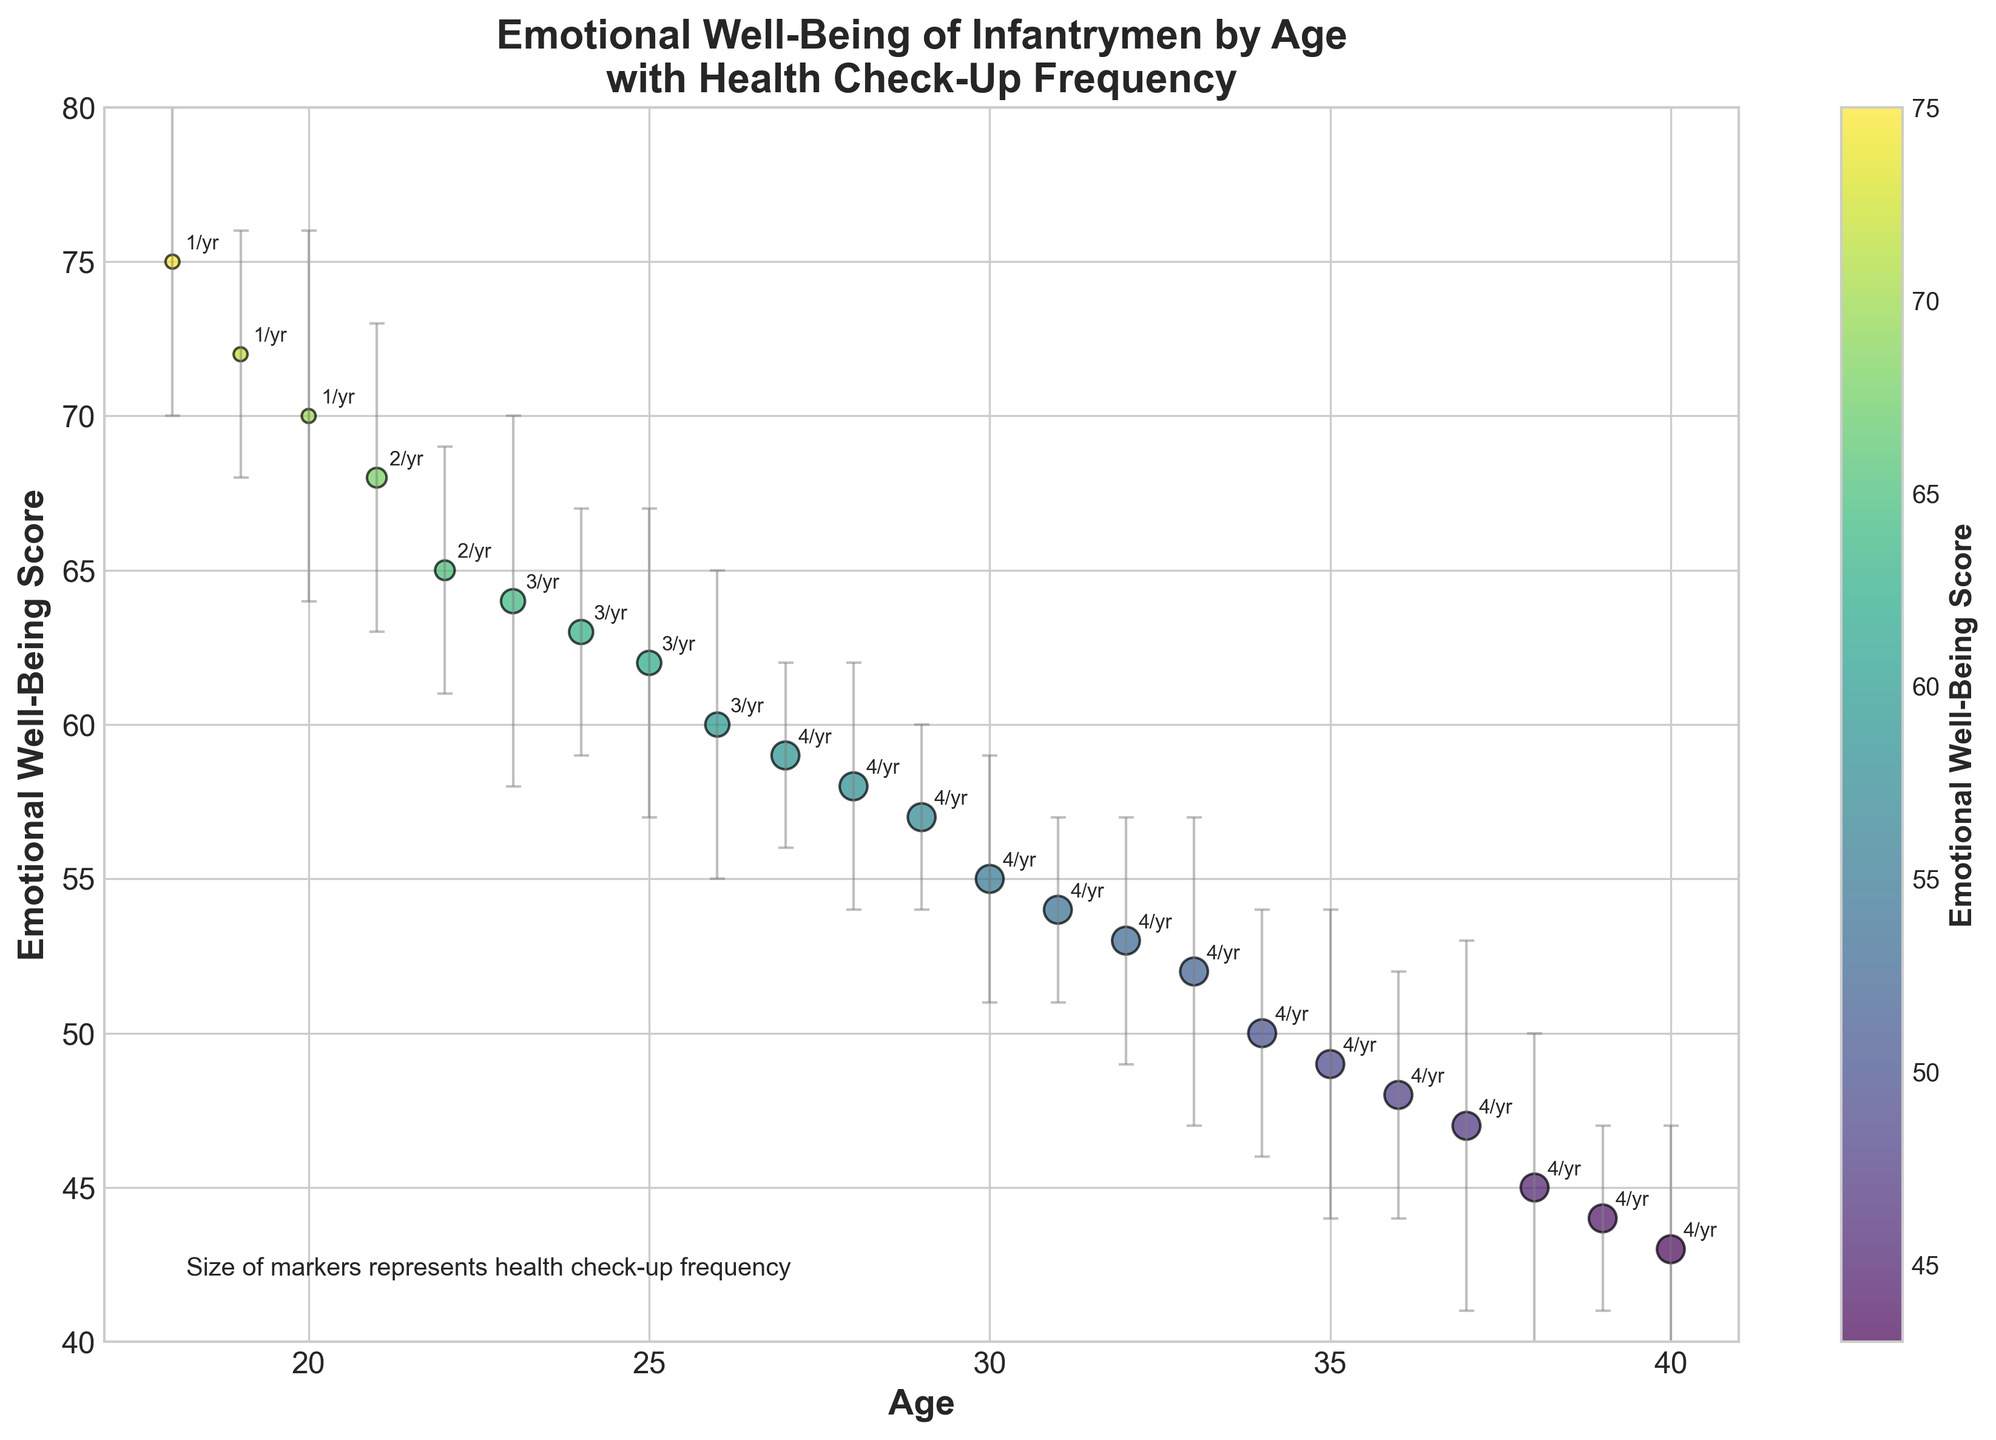What is the title of the figure? The title of the figure is usually found at the top center and describes the content or purpose of the visualization. In this case, it reads "Emotional Well-Being of Infantrymen by Age\nwith Health Check-Up Frequency".
Answer: Emotional Well-Being of Infantrymen by Age with Health Check-Up Frequency What is the color range used in the scatter plot for Emotional Well-Being Scores? The color range can be identified by looking at the color bar, which shows the gradient from one color to another based on the emotional well-being scores. Here, it ranges from green to yellow.
Answer: Green to yellow How many data points are shown in the figure? We can count the bubble markers present in the scatter plot to determine the number of data points. Each bubble represents one data point. There are a total of 23 data points.
Answer: 23 At what age does the Emotional Well-Being Score have the highest error margin? The error margins are represented by the vertical error bars. By comparing the length of these bars, we see the longest at age 20 and age 37, both having the longest error bars.
Answer: 20 and 37 What is the Emotional Well-Being Score for infantrymen aged 25? By looking at the 25 on the X-axis and tracing it upwards to the corresponding bubble, we find that the score is 62.
Answer: 62 Between ages 30 and 40, which age group has the lowest Emotional Well-Being Score? We compare the y-axis values for ages from 30 to 40 and find that the lowest bubble (closest to 40 on the y-axis) occurs at age 40 with an Emotional Well-Being Score of 43.
Answer: 40 What is the approximate average Emotional Well-Being Score for infantrymen aged 30 to 35? To compute the average, we take the sum of the scores at 30, 31, 32, 33, 34, and 35 and then divide by the number of values. Scores: 55, 54, 53, 52, 50, 49. Sum = 313. Average = 313 / 6 = ~52.167.
Answer: ~52.167 What trend do you observe between Emotional Well-Being Scores and increasing Age? The scatter plot shows that as age increases, Emotional Well-Being Scores generally decrease, showing a downward trend.
Answer: Decreases How does the check-up frequency relate to Emotional Well-Being Scores for infantrymen aged between 18 and 22? By looking at the sizes of the bubbles (which represent check-up frequency) and their corresponding y-values for ages 18 to 22, we see that check-up frequency increases slightly while Emotional Well-Being Scores decrease as age increases from 75 to 65.
Answer: Increased check-up frequency, decreased well-being scores What age group has the highest Emotional Well-Being Score and what is the check-up frequency for that age? The highest score is identified by the highest point on the y-axis, which corresponds to age 18 with a score of 75. The check-up frequency for this age is indicated by the size of the bubble, which is 1 per year.
Answer: 18, 1 per year 